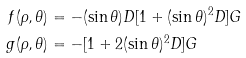<formula> <loc_0><loc_0><loc_500><loc_500>f ( \rho , \theta ) & = - ( \sin \theta ) D [ 1 + ( \sin \theta ) ^ { 2 } D ] G \\ g ( \rho , \theta ) & = - [ 1 + 2 ( \sin \theta ) ^ { 2 } D ] G</formula> 